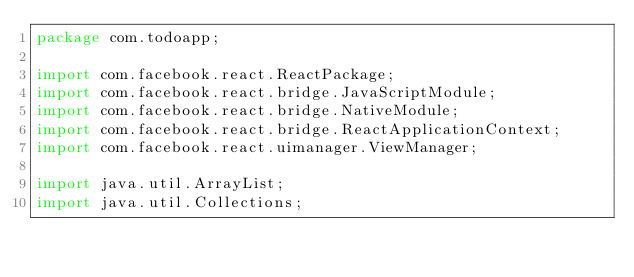<code> <loc_0><loc_0><loc_500><loc_500><_Java_>package com.todoapp;

import com.facebook.react.ReactPackage;
import com.facebook.react.bridge.JavaScriptModule;
import com.facebook.react.bridge.NativeModule;
import com.facebook.react.bridge.ReactApplicationContext;
import com.facebook.react.uimanager.ViewManager;

import java.util.ArrayList;
import java.util.Collections;</code> 